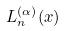Convert formula to latex. <formula><loc_0><loc_0><loc_500><loc_500>L _ { n } ^ { ( \alpha ) } ( x )</formula> 